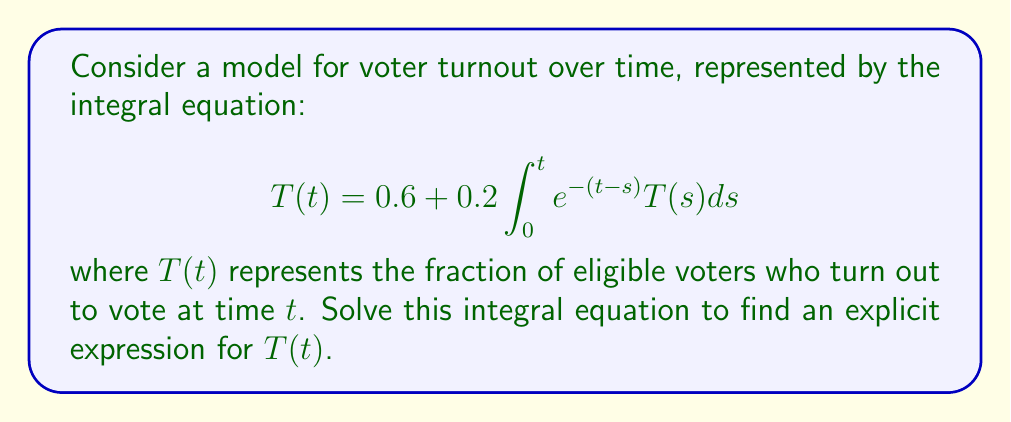Give your solution to this math problem. To solve this integral equation, we'll follow these steps:

1) First, let's differentiate both sides of the equation with respect to $t$:

   $$\frac{d}{dt}T(t) = 0.2e^{-t}\int_0^t e^sT(s)ds + 0.2T(t)$$

2) Now, let's define a new function $I(t) = \int_0^t e^sT(s)ds$. Then we can rewrite our equation as:

   $$T'(t) = 0.2e^{-t}I(t) + 0.2T(t)$$

3) We also note that $I'(t) = e^tT(t)$.

4) Now, let's differentiate the original equation again:

   $$T''(t) = -0.2e^{-t}I(t) + 0.2e^{-t}I'(t) + 0.2T'(t)$$

5) Substituting $I'(t) = e^tT(t)$ and the expression for $T'(t)$ from step 2:

   $$T''(t) = -0.2e^{-t}I(t) + 0.2T(t) + 0.2(0.2e^{-t}I(t) + 0.2T(t))$$

6) Simplifying:

   $$T''(t) = 0.24T(t)$$

7) This is a second-order linear differential equation. The general solution is:

   $$T(t) = Ae^{\sqrt{0.24}t} + Be^{-\sqrt{0.24}t}$$

8) To find $A$ and $B$, we use the initial conditions. From the original equation, we can see that $T(0) = 0.6$.

9) We can find $T'(0)$ from the equation in step 2:
   
   $$T'(0) = 0.2I(0) + 0.2T(0) = 0.2 \cdot 0 + 0.2 \cdot 0.6 = 0.12$$

10) Using these conditions:

    $$0.6 = A + B$$
    $$0.12 = \sqrt{0.24}A - \sqrt{0.24}B$$

11) Solving this system of equations:

    $$A = 0.3 + 0.1225, B = 0.3 - 0.1225$$

12) Therefore, the final solution is:

    $$T(t) = (0.3 + 0.1225)e^{\sqrt{0.24}t} + (0.3 - 0.1225)e^{-\sqrt{0.24}t}$$
Answer: $T(t) = (0.3 + 0.1225)e^{\sqrt{0.24}t} + (0.3 - 0.1225)e^{-\sqrt{0.24}t}$ 